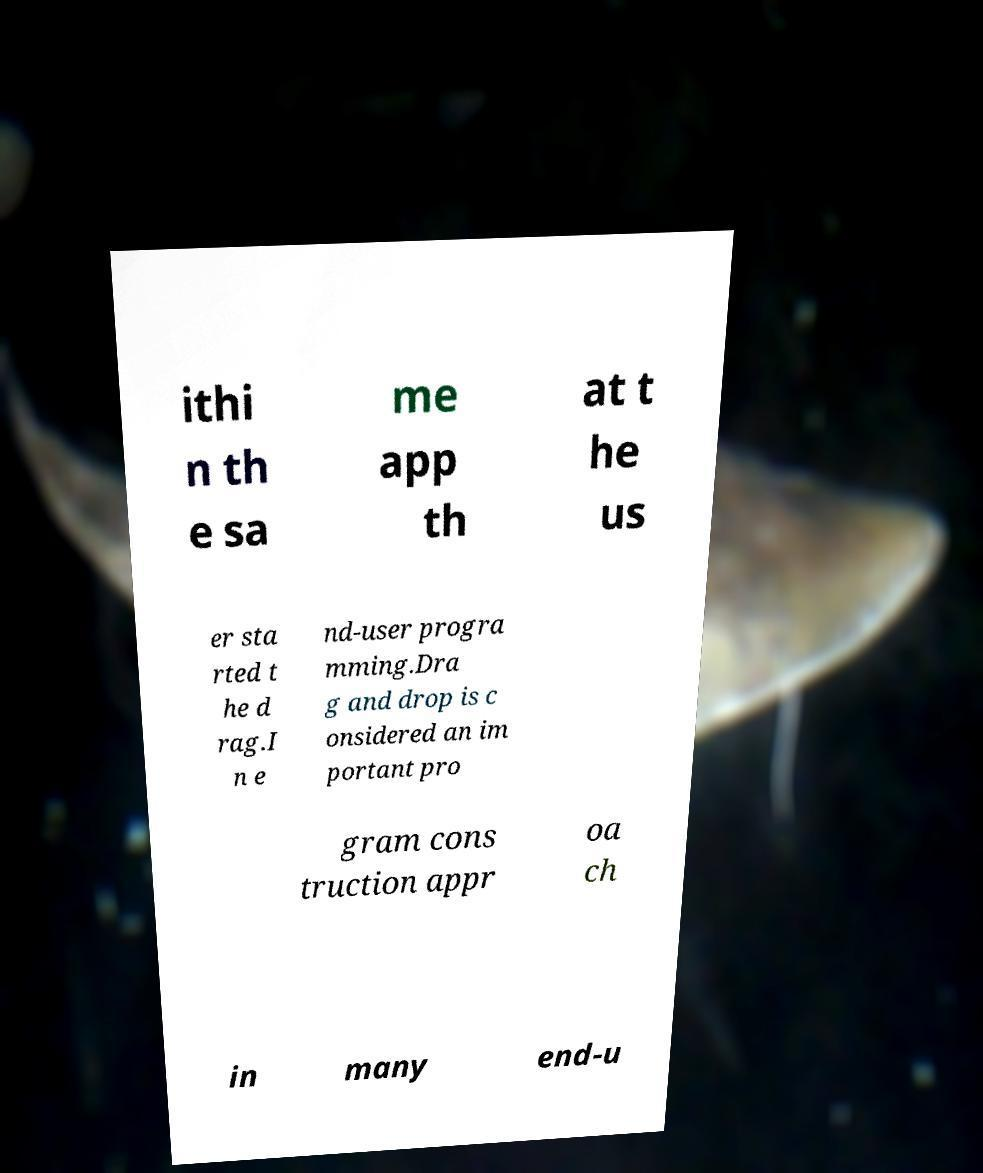Can you accurately transcribe the text from the provided image for me? ithi n th e sa me app th at t he us er sta rted t he d rag.I n e nd-user progra mming.Dra g and drop is c onsidered an im portant pro gram cons truction appr oa ch in many end-u 